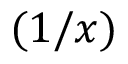<formula> <loc_0><loc_0><loc_500><loc_500>( 1 / x )</formula> 